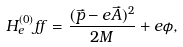<formula> <loc_0><loc_0><loc_500><loc_500>H ^ { ( 0 ) } _ { e } f f = \frac { ( \vec { p } - e \vec { A } ) ^ { 2 } } { 2 M } + e \phi ,</formula> 